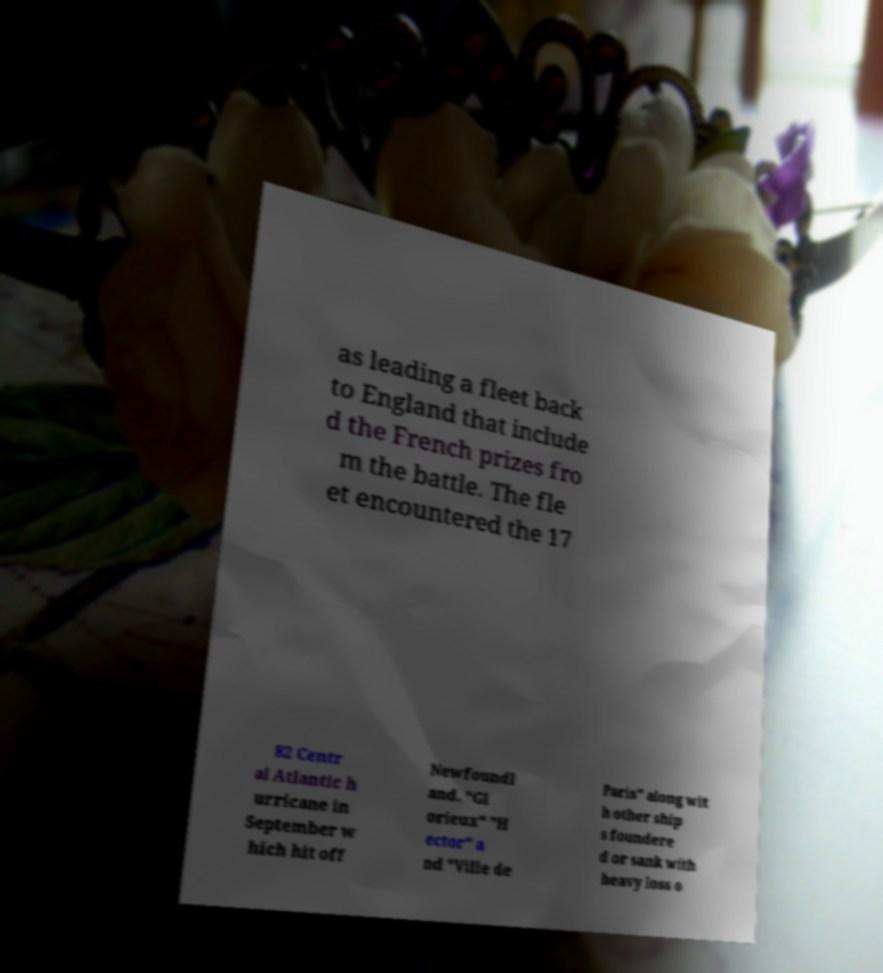I need the written content from this picture converted into text. Can you do that? as leading a fleet back to England that include d the French prizes fro m the battle. The fle et encountered the 17 82 Centr al Atlantic h urricane in September w hich hit off Newfoundl and. "Gl orieux" "H ector" a nd "Ville de Paris" along wit h other ship s foundere d or sank with heavy loss o 